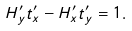<formula> <loc_0><loc_0><loc_500><loc_500>H ^ { \prime } _ { y } t ^ { \prime } _ { x } - H ^ { \prime } _ { x } t ^ { \prime } _ { y } = 1 .</formula> 